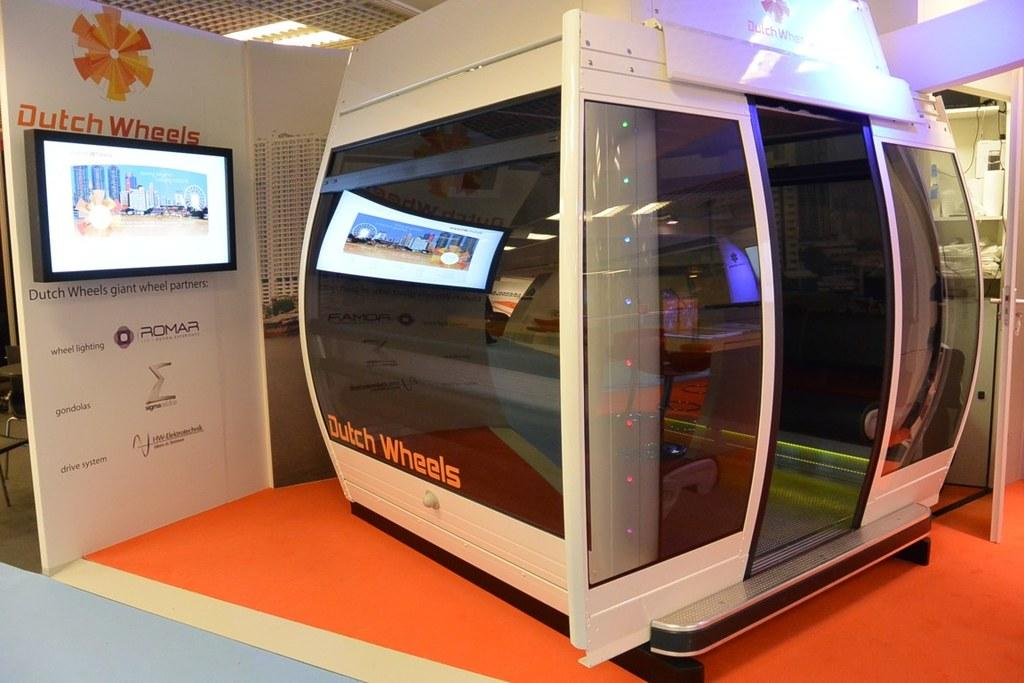Provide a one-sentence caption for the provided image. Inside simulator device that says Dutch Wheels, says Giant Wheel Partners: Romar. 